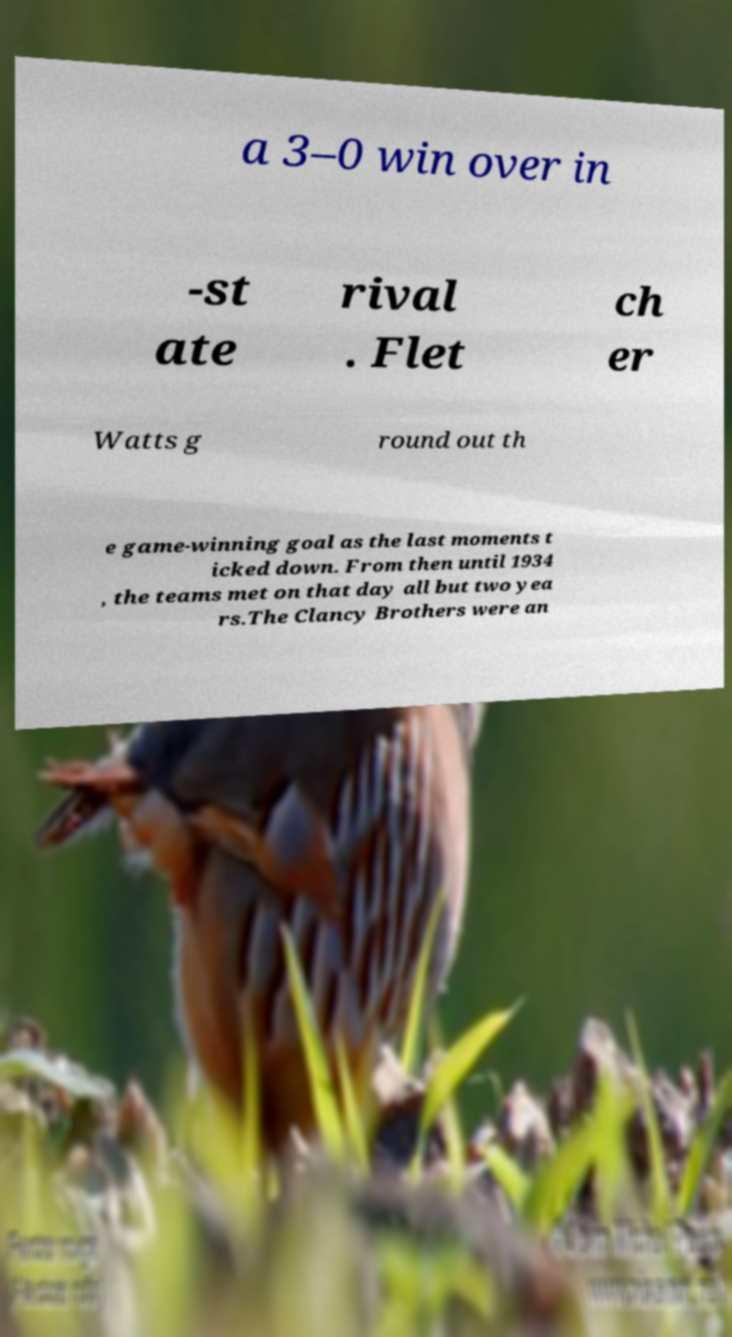Could you assist in decoding the text presented in this image and type it out clearly? a 3–0 win over in -st ate rival . Flet ch er Watts g round out th e game-winning goal as the last moments t icked down. From then until 1934 , the teams met on that day all but two yea rs.The Clancy Brothers were an 